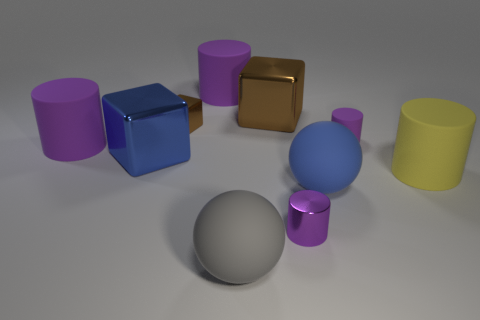How do the textures of the objects in the image differ? The objects in the image display a variety of textures. The blue cube shows a glossy finish that reflects light, giving it a shiny look. The gold cube has a metallic sheen, and the cylinders appear smooth, with the silver ones having reflective surfaces and the colored ones featuring a matte finish. The sphere has a slightly more subtle, diffuse reflection, which might suggest a satiny texture. 